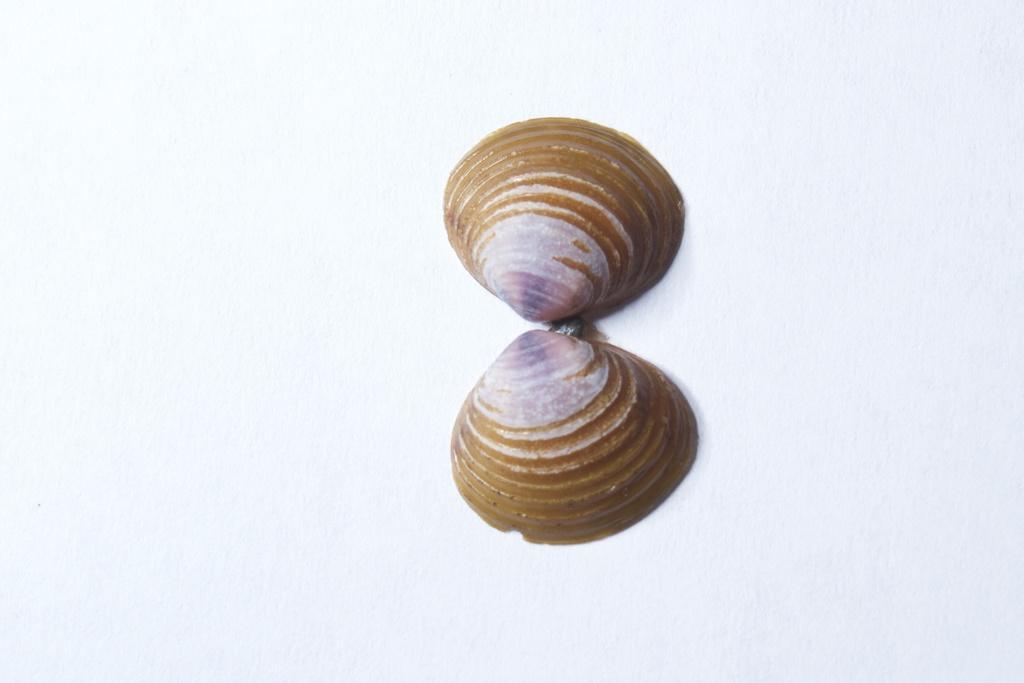Describe this image in one or two sentences. In the image we can see the sea shells kept on the white surface. 